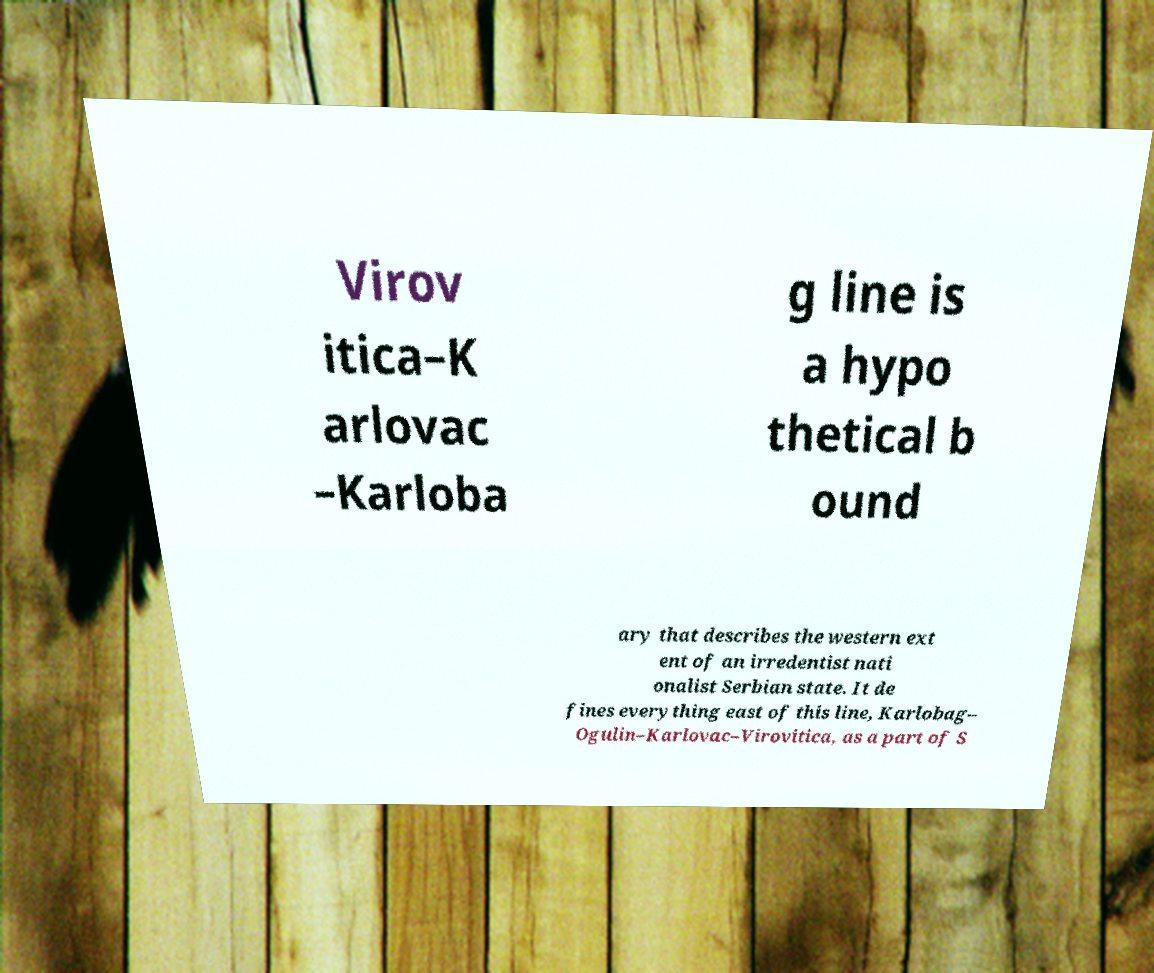Can you accurately transcribe the text from the provided image for me? Virov itica–K arlovac –Karloba g line is a hypo thetical b ound ary that describes the western ext ent of an irredentist nati onalist Serbian state. It de fines everything east of this line, Karlobag– Ogulin–Karlovac–Virovitica, as a part of S 